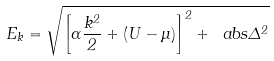Convert formula to latex. <formula><loc_0><loc_0><loc_500><loc_500>E _ { k } = \sqrt { \left [ \alpha \frac { k ^ { 2 } } { 2 } + ( U - \mu ) \right ] ^ { 2 } + \ a b s { \Delta } ^ { 2 } }</formula> 